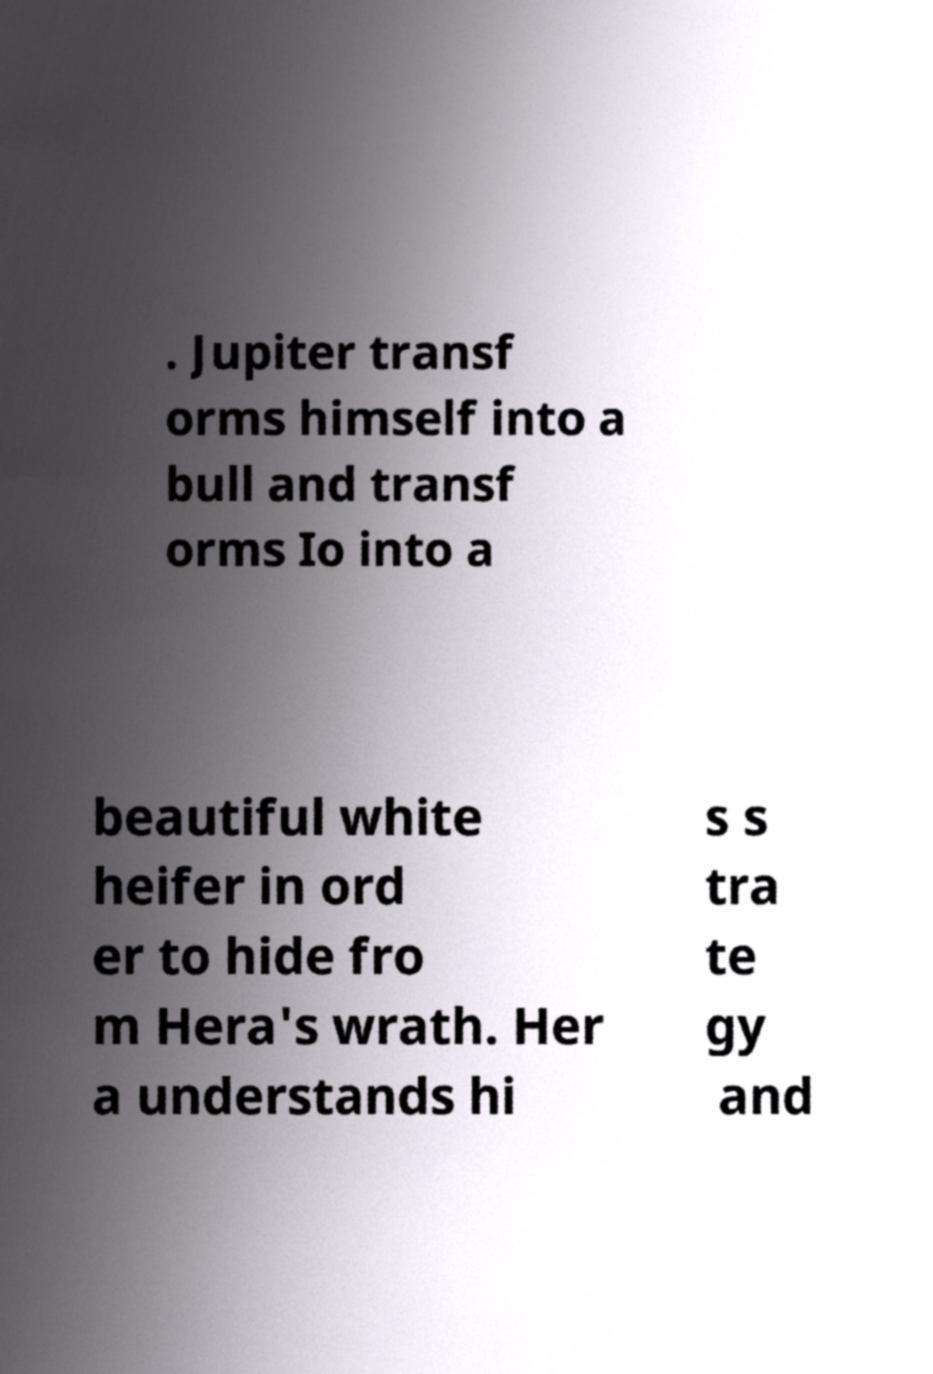For documentation purposes, I need the text within this image transcribed. Could you provide that? . Jupiter transf orms himself into a bull and transf orms Io into a beautiful white heifer in ord er to hide fro m Hera's wrath. Her a understands hi s s tra te gy and 